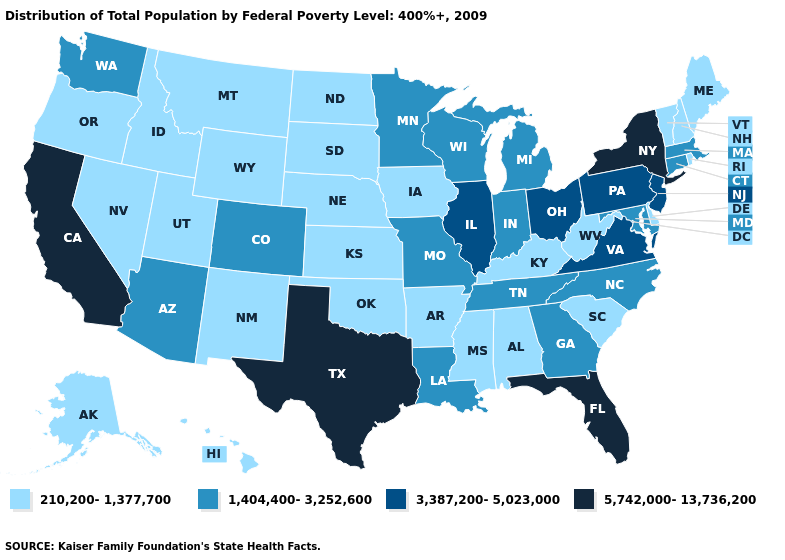What is the value of Rhode Island?
Keep it brief. 210,200-1,377,700. What is the value of Indiana?
Keep it brief. 1,404,400-3,252,600. What is the lowest value in the MidWest?
Concise answer only. 210,200-1,377,700. Among the states that border Kansas , which have the lowest value?
Give a very brief answer. Nebraska, Oklahoma. What is the value of Florida?
Quick response, please. 5,742,000-13,736,200. Name the states that have a value in the range 3,387,200-5,023,000?
Short answer required. Illinois, New Jersey, Ohio, Pennsylvania, Virginia. What is the value of Utah?
Be succinct. 210,200-1,377,700. Name the states that have a value in the range 210,200-1,377,700?
Answer briefly. Alabama, Alaska, Arkansas, Delaware, Hawaii, Idaho, Iowa, Kansas, Kentucky, Maine, Mississippi, Montana, Nebraska, Nevada, New Hampshire, New Mexico, North Dakota, Oklahoma, Oregon, Rhode Island, South Carolina, South Dakota, Utah, Vermont, West Virginia, Wyoming. What is the highest value in states that border Rhode Island?
Keep it brief. 1,404,400-3,252,600. What is the value of California?
Keep it brief. 5,742,000-13,736,200. What is the value of Kansas?
Short answer required. 210,200-1,377,700. Does the first symbol in the legend represent the smallest category?
Keep it brief. Yes. What is the value of Georgia?
Short answer required. 1,404,400-3,252,600. What is the value of Arkansas?
Short answer required. 210,200-1,377,700. Which states have the lowest value in the USA?
Give a very brief answer. Alabama, Alaska, Arkansas, Delaware, Hawaii, Idaho, Iowa, Kansas, Kentucky, Maine, Mississippi, Montana, Nebraska, Nevada, New Hampshire, New Mexico, North Dakota, Oklahoma, Oregon, Rhode Island, South Carolina, South Dakota, Utah, Vermont, West Virginia, Wyoming. 